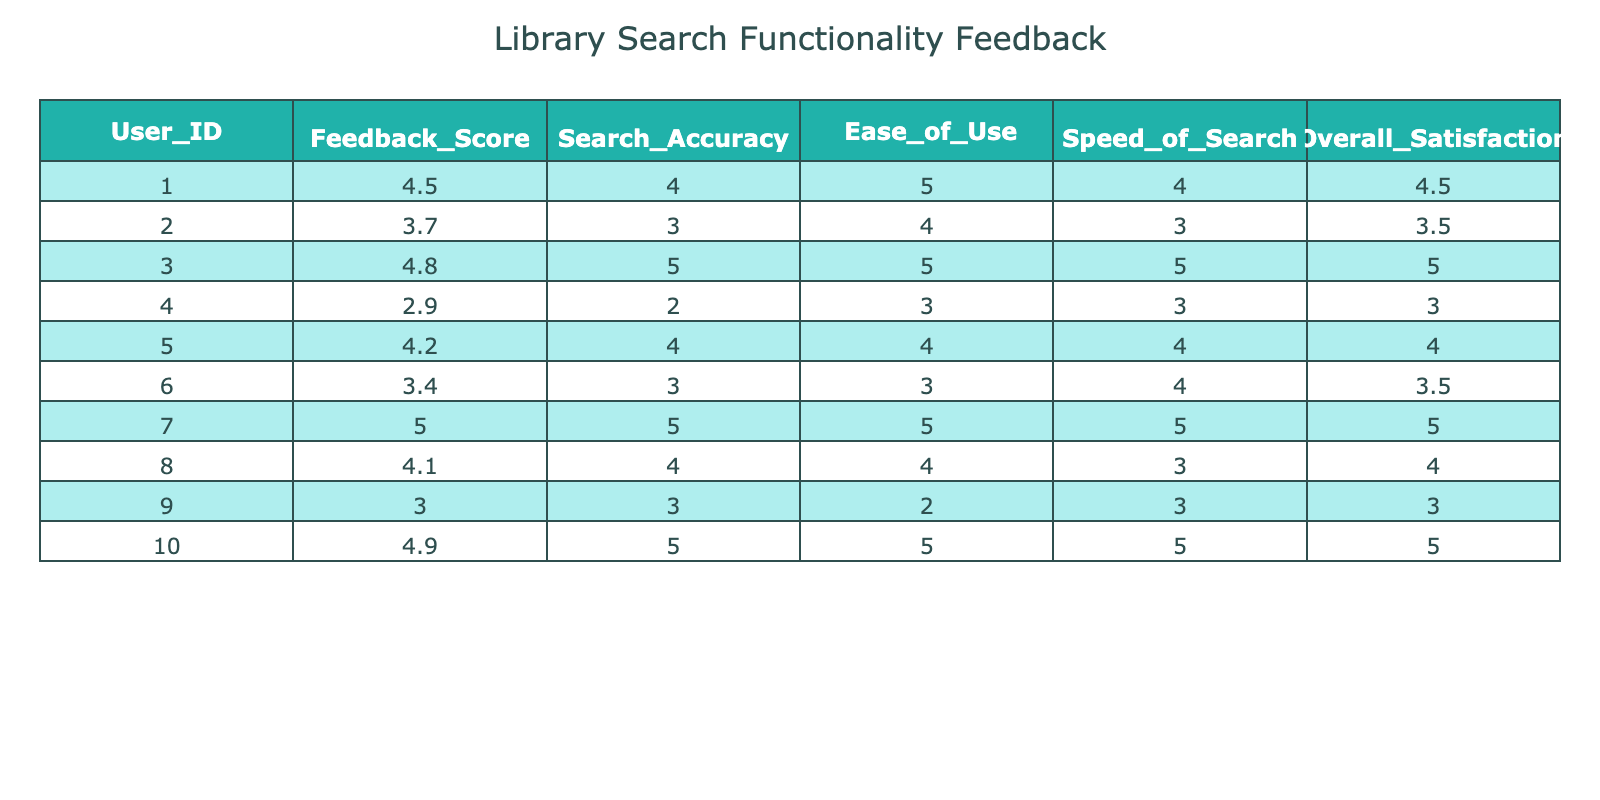What is the feedback score of user ID 005? According to the table, the Feedback Score corresponding to User ID 005 is explicitly listed in that row. It shows a value of 4.2.
Answer: 4.2 What is the highest Overall Satisfaction score among all users? After examining the Overall Satisfaction column, the highest value appears to be 5.0, which corresponds to users 003 and 007.
Answer: 5.0 What is the average Search Accuracy score from all users? To compute the average, sum all the Search Accuracy scores: (4 + 3 + 5 + 2 + 4 + 3 + 5 + 4 + 3 + 5) = 43. There are 10 users, so the average is 43 / 10 = 4.3.
Answer: 4.3 Is there any user with a Feedback Score below 3? By reviewing the Feedback Score column, I found User ID 004 has a score of 2.9 which is indeed below 3. Hence, the answer is yes.
Answer: Yes What is the difference between the maximum and minimum Ease of Use scores? The maximum Ease of Use score is 5 (from users 003, 007, and 010), while the minimum score is 2 (from user 009). The difference is calculated as 5 - 2 = 3.
Answer: 3 Which user has the lowest Speed of Search score, and what is it? When scanning the Speed of Search column, user ID 002 has the lowest score at 3. This is the lowest value in that column among all users.
Answer: User ID 002, score 3 How many users rated the Search Accuracy score of 5? In the Search Accuracy column, the scores of 5 are noted for user IDs 003, 007, and 010. Counting these entries shows that a total of 3 users rated it as 5.
Answer: 3 What is the combined Overall Satisfaction score of users with Feedback Scores above 4? The users with Feedback Scores above 4 are user IDs 001, 003, 005, 007, 010. Their corresponding Overall Satisfaction scores are 4.5, 5.0, 4.0, 5.0, and 5.0. Adding these scores gives: 4.5 + 5.0 + 4.0 + 5.0 + 5.0 = 23.5.
Answer: 23.5 Does any user have an Ease of Use score equal to 4? Inspecting the Ease of Use column reveals multiple users, specifically user IDs 005, 008, and 001, have a score of 4. Thus, the answer is yes.
Answer: Yes 